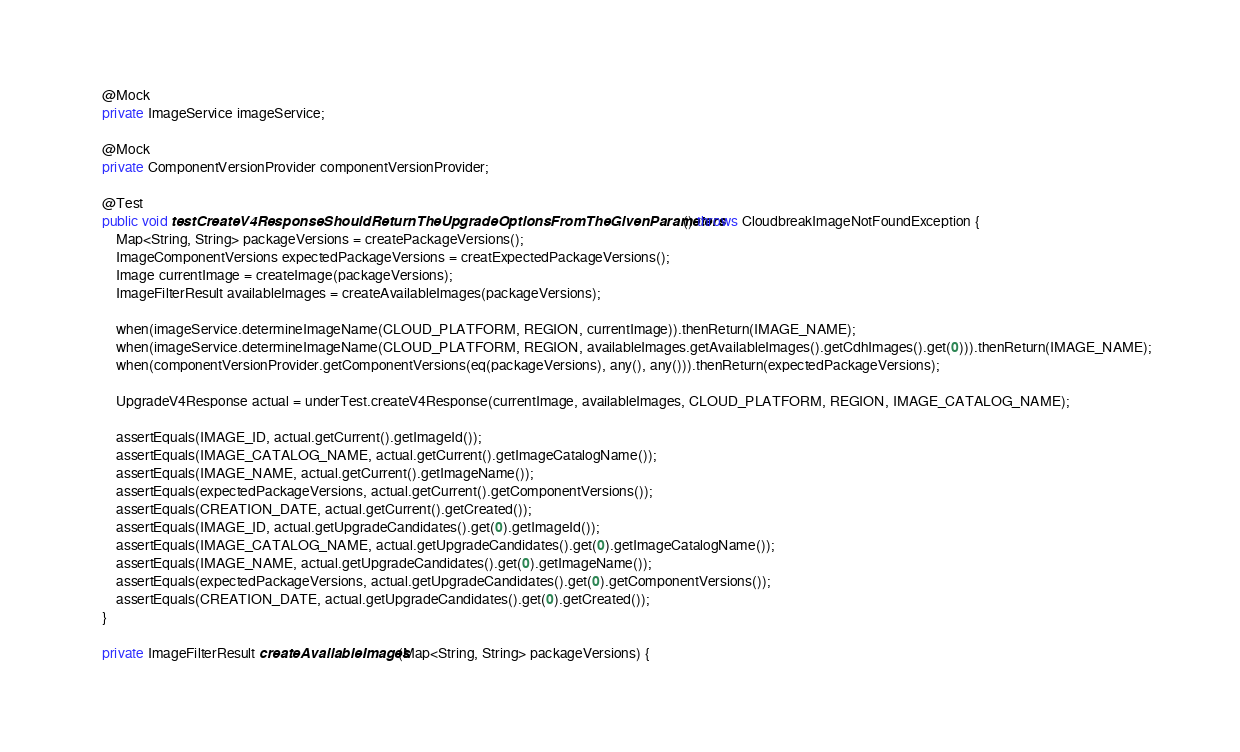Convert code to text. <code><loc_0><loc_0><loc_500><loc_500><_Java_>    @Mock
    private ImageService imageService;

    @Mock
    private ComponentVersionProvider componentVersionProvider;

    @Test
    public void testCreateV4ResponseShouldReturnTheUpgradeOptionsFromTheGivenParameters() throws CloudbreakImageNotFoundException {
        Map<String, String> packageVersions = createPackageVersions();
        ImageComponentVersions expectedPackageVersions = creatExpectedPackageVersions();
        Image currentImage = createImage(packageVersions);
        ImageFilterResult availableImages = createAvailableImages(packageVersions);

        when(imageService.determineImageName(CLOUD_PLATFORM, REGION, currentImage)).thenReturn(IMAGE_NAME);
        when(imageService.determineImageName(CLOUD_PLATFORM, REGION, availableImages.getAvailableImages().getCdhImages().get(0))).thenReturn(IMAGE_NAME);
        when(componentVersionProvider.getComponentVersions(eq(packageVersions), any(), any())).thenReturn(expectedPackageVersions);

        UpgradeV4Response actual = underTest.createV4Response(currentImage, availableImages, CLOUD_PLATFORM, REGION, IMAGE_CATALOG_NAME);

        assertEquals(IMAGE_ID, actual.getCurrent().getImageId());
        assertEquals(IMAGE_CATALOG_NAME, actual.getCurrent().getImageCatalogName());
        assertEquals(IMAGE_NAME, actual.getCurrent().getImageName());
        assertEquals(expectedPackageVersions, actual.getCurrent().getComponentVersions());
        assertEquals(CREATION_DATE, actual.getCurrent().getCreated());
        assertEquals(IMAGE_ID, actual.getUpgradeCandidates().get(0).getImageId());
        assertEquals(IMAGE_CATALOG_NAME, actual.getUpgradeCandidates().get(0).getImageCatalogName());
        assertEquals(IMAGE_NAME, actual.getUpgradeCandidates().get(0).getImageName());
        assertEquals(expectedPackageVersions, actual.getUpgradeCandidates().get(0).getComponentVersions());
        assertEquals(CREATION_DATE, actual.getUpgradeCandidates().get(0).getCreated());
    }

    private ImageFilterResult createAvailableImages(Map<String, String> packageVersions) {</code> 